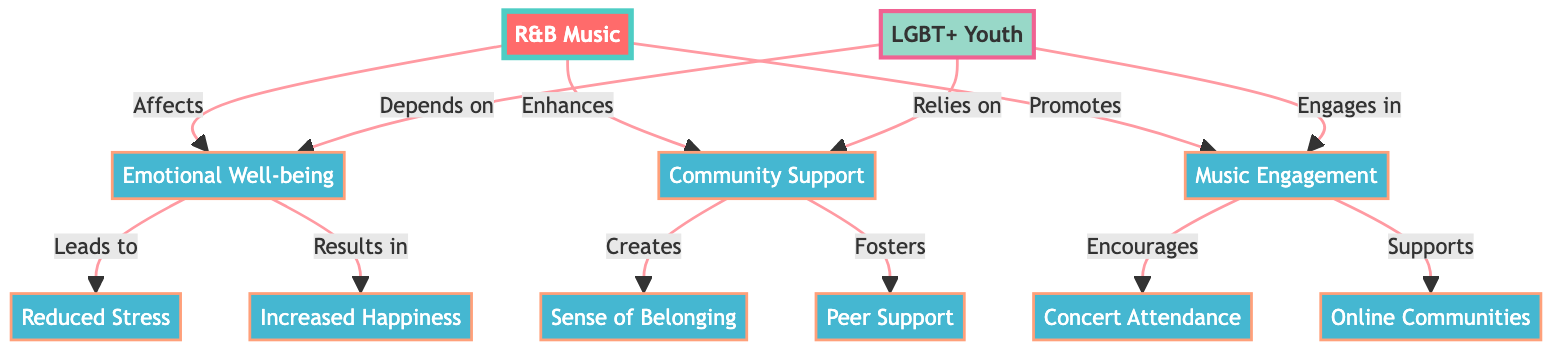What are the main effects of R&B music on emotional well-being? The diagram indicates that R&B music affects emotional well-being, specifically leading to reduced stress and increased happiness. Therefore, the main effects mentioned are those two outcomes.
Answer: Reduced stress, Increased happiness How many nodes are connected to LGBT+ Youth? By reviewing the diagram, we see that there are three direct connections to LGBT+ Youth—Emotional Well-being, Community Support, and Music Engagement. Each of these connections indicates a specific aspect that LGBT+ Youth relies on.
Answer: 3 What does R&B music promote according to the diagram? The diagram states that R&B music promotes music engagement. This means that through listening and participating in R&B music, there’s an encouragement for youth to engage with music, which is a specific outcome highlighted in the diagram.
Answer: Music engagement How does community support affect LGBT+ youth? According to the diagram, community support creates a sense of belonging and fosters peer support among LGBT+ youth. This indicates that community support has a positive impact by enhancing social connections and feelings of acceptance.
Answer: Sense of belonging, Peer support Which connection indicates a direct relationship between emotional well-being and stress reduction? The arrow from Emotional Well-being pointing to Reduced Stress indicates a direct relationship between these two nodes. This means that an improvement in emotional well-being is associated with reduced stress levels among LGBT+ youth.
Answer: Reduced Stress 